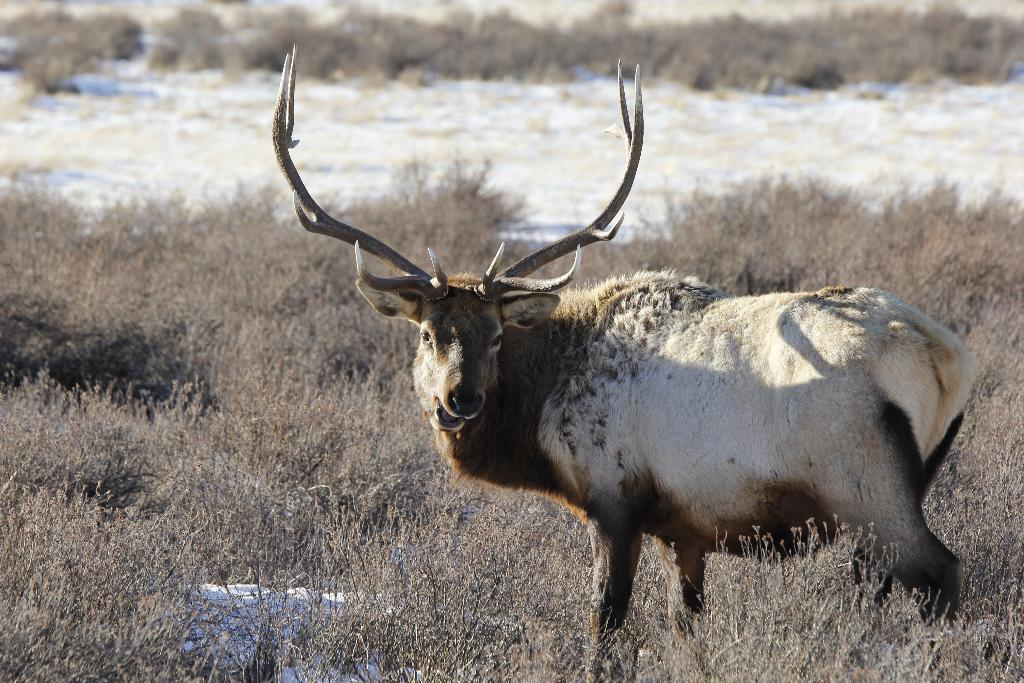What type of creature can be seen in the image? There is an animal in the image. Can you describe the environment in which the animal is situated? The animal is standing between dry plants. What type of support does the animal use to stand on in the image? The animal does not use any visible support to stand on in the image. What material is the animal made of in the image? The animal is a living creature and not made of any material in the image. 